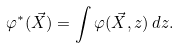Convert formula to latex. <formula><loc_0><loc_0><loc_500><loc_500>\varphi ^ { * } ( { \vec { X } } ) = \int \varphi ( { \vec { X } } , z ) \, d z .</formula> 